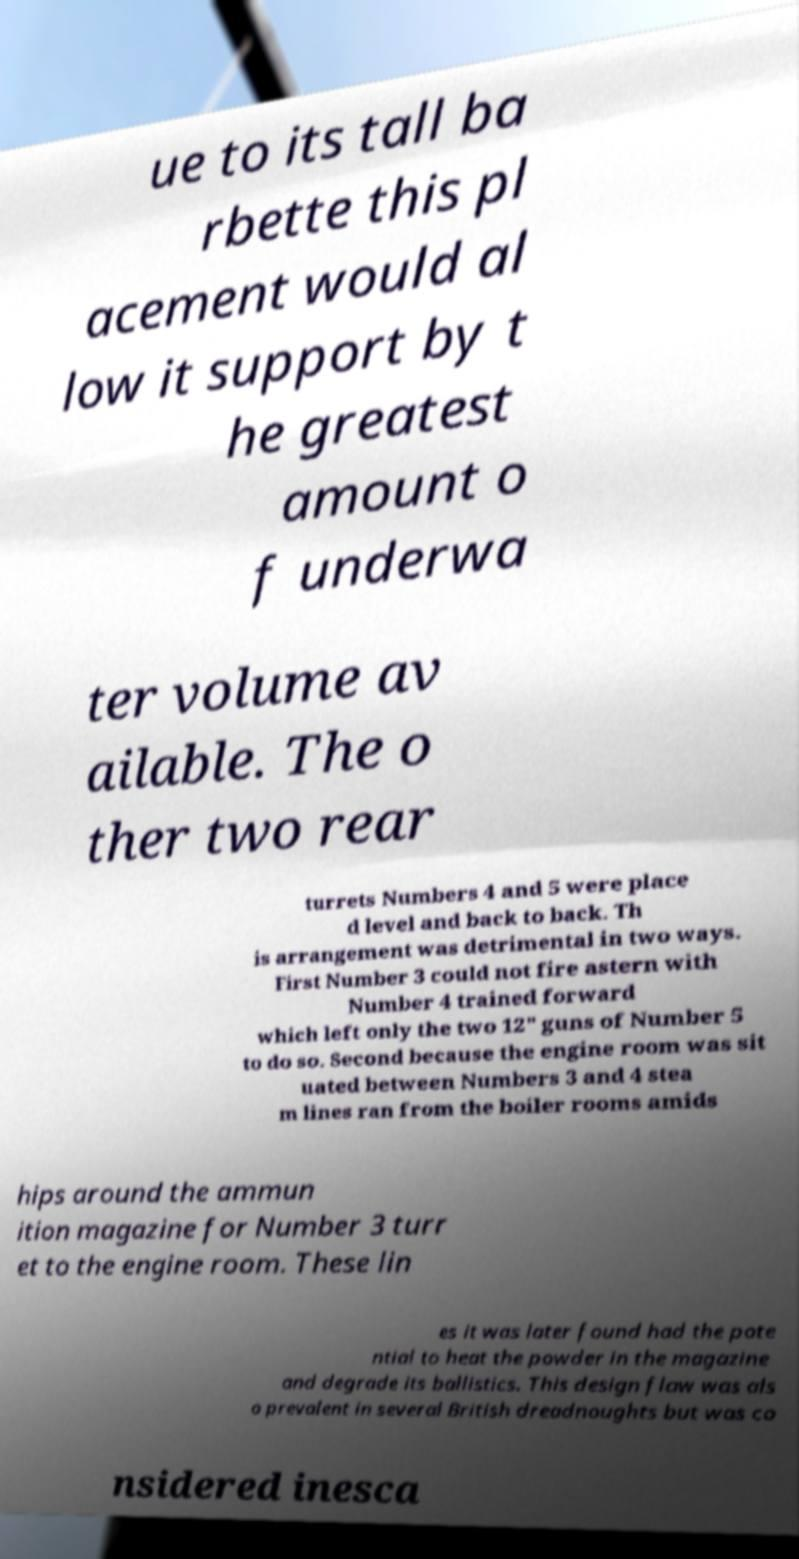What messages or text are displayed in this image? I need them in a readable, typed format. ue to its tall ba rbette this pl acement would al low it support by t he greatest amount o f underwa ter volume av ailable. The o ther two rear turrets Numbers 4 and 5 were place d level and back to back. Th is arrangement was detrimental in two ways. First Number 3 could not fire astern with Number 4 trained forward which left only the two 12" guns of Number 5 to do so. Second because the engine room was sit uated between Numbers 3 and 4 stea m lines ran from the boiler rooms amids hips around the ammun ition magazine for Number 3 turr et to the engine room. These lin es it was later found had the pote ntial to heat the powder in the magazine and degrade its ballistics. This design flaw was als o prevalent in several British dreadnoughts but was co nsidered inesca 